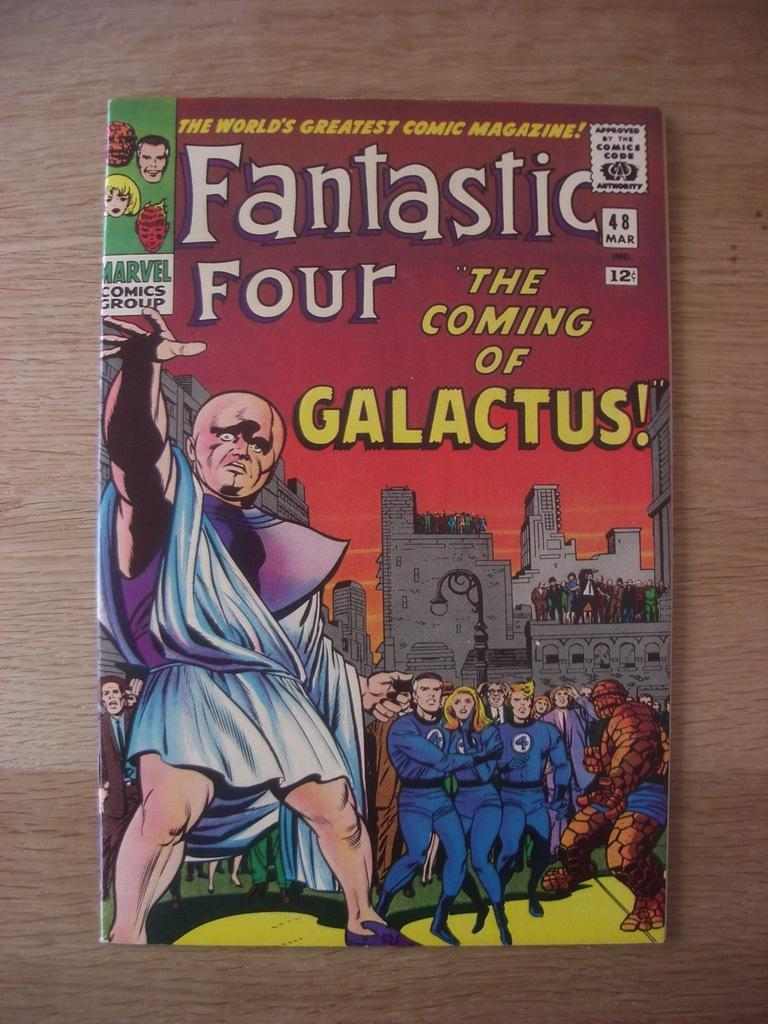<image>
Give a short and clear explanation of the subsequent image. A Fantastic Four comic book has villain with a bald head on the cover. 